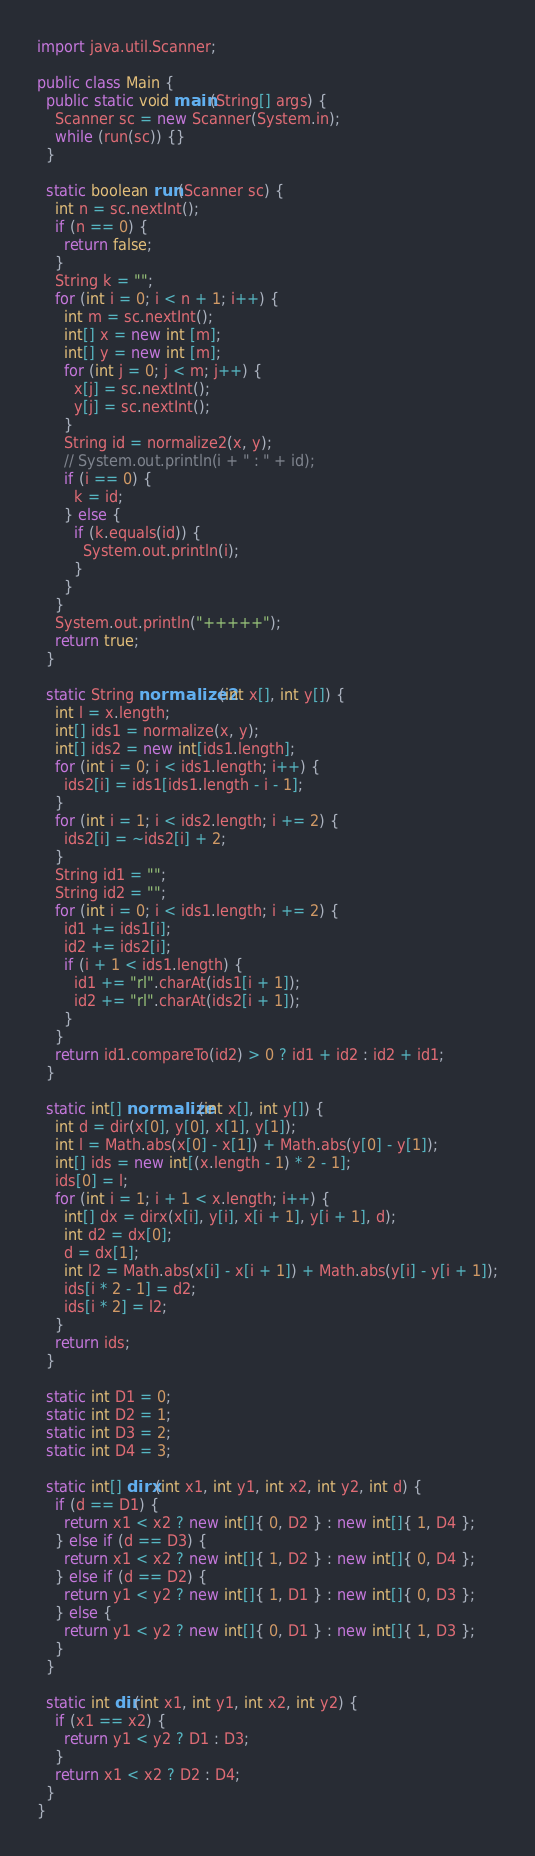<code> <loc_0><loc_0><loc_500><loc_500><_Java_>import java.util.Scanner;

public class Main {
  public static void main(String[] args) {
    Scanner sc = new Scanner(System.in);
    while (run(sc)) {}
  }

  static boolean run(Scanner sc) {
    int n = sc.nextInt();
    if (n == 0) {
      return false;
    }
    String k = "";
    for (int i = 0; i < n + 1; i++) {
      int m = sc.nextInt();
      int[] x = new int [m];
      int[] y = new int [m];
      for (int j = 0; j < m; j++) {
        x[j] = sc.nextInt();
        y[j] = sc.nextInt();
      }
      String id = normalize2(x, y);
      // System.out.println(i + " : " + id);
      if (i == 0) {
        k = id;
      } else {
        if (k.equals(id)) {
          System.out.println(i);
        }
      }
    }
    System.out.println("+++++");
    return true;
  }

  static String normalize2(int x[], int y[]) {
    int l = x.length;
    int[] ids1 = normalize(x, y);
    int[] ids2 = new int[ids1.length];
    for (int i = 0; i < ids1.length; i++) {
      ids2[i] = ids1[ids1.length - i - 1];
    }
    for (int i = 1; i < ids2.length; i += 2) {
      ids2[i] = ~ids2[i] + 2;
    }
    String id1 = "";
    String id2 = "";
    for (int i = 0; i < ids1.length; i += 2) {
      id1 += ids1[i];
      id2 += ids2[i];
      if (i + 1 < ids1.length) {
        id1 += "rl".charAt(ids1[i + 1]);
        id2 += "rl".charAt(ids2[i + 1]);
      }
    }
    return id1.compareTo(id2) > 0 ? id1 + id2 : id2 + id1;
  }

  static int[] normalize(int x[], int y[]) {
    int d = dir(x[0], y[0], x[1], y[1]);
    int l = Math.abs(x[0] - x[1]) + Math.abs(y[0] - y[1]);
    int[] ids = new int[(x.length - 1) * 2 - 1];
    ids[0] = l;
    for (int i = 1; i + 1 < x.length; i++) {
      int[] dx = dirx(x[i], y[i], x[i + 1], y[i + 1], d);
      int d2 = dx[0];
      d = dx[1];
      int l2 = Math.abs(x[i] - x[i + 1]) + Math.abs(y[i] - y[i + 1]);
      ids[i * 2 - 1] = d2;
      ids[i * 2] = l2;
    }
    return ids;
  }

  static int D1 = 0;
  static int D2 = 1;
  static int D3 = 2;
  static int D4 = 3;

  static int[] dirx(int x1, int y1, int x2, int y2, int d) {
    if (d == D1) {
      return x1 < x2 ? new int[]{ 0, D2 } : new int[]{ 1, D4 };
    } else if (d == D3) {
      return x1 < x2 ? new int[]{ 1, D2 } : new int[]{ 0, D4 };
    } else if (d == D2) {
      return y1 < y2 ? new int[]{ 1, D1 } : new int[]{ 0, D3 };
    } else {
      return y1 < y2 ? new int[]{ 0, D1 } : new int[]{ 1, D3 };
    }
  }

  static int dir(int x1, int y1, int x2, int y2) {
    if (x1 == x2) {
      return y1 < y2 ? D1 : D3;
    }
    return x1 < x2 ? D2 : D4;
  }
}</code> 